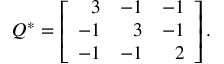<formula> <loc_0><loc_0><loc_500><loc_500>Q ^ { \ast } = \left [ { \begin{array} { r r r } { 3 } & { - 1 } & { - 1 } \\ { - 1 } & { 3 } & { - 1 } \\ { - 1 } & { - 1 } & { 2 } \end{array} } \right ] .</formula> 